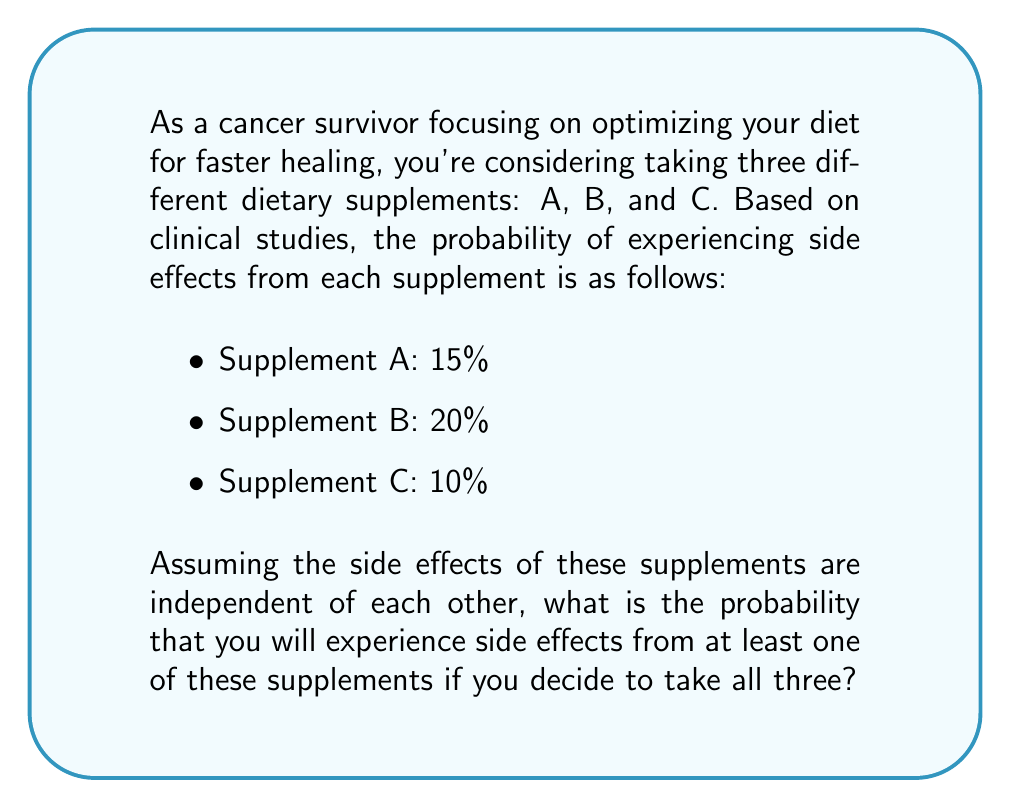Help me with this question. To solve this problem, we'll use the concept of probability of the complement event. Instead of calculating the probability of experiencing side effects from at least one supplement directly, we'll calculate the probability of not experiencing side effects from any of the supplements and then subtract that from 1.

Let's break it down step-by-step:

1) First, let's calculate the probability of not experiencing side effects for each supplement:
   - Supplement A: $1 - 0.15 = 0.85$ or $85\%$
   - Supplement B: $1 - 0.20 = 0.80$ or $80\%$
   - Supplement C: $1 - 0.10 = 0.90$ or $90\%$

2) Since the side effects are independent, the probability of not experiencing side effects from any of the supplements is the product of the individual probabilities:

   $$P(\text{no side effects}) = 0.85 \times 0.80 \times 0.90 = 0.612$$

3) Therefore, the probability of experiencing side effects from at least one supplement is the complement of this probability:

   $$P(\text{at least one side effect}) = 1 - P(\text{no side effects})$$
   $$P(\text{at least one side effect}) = 1 - 0.612 = 0.388$$

4) Converting to a percentage:

   $$0.388 \times 100\% = 38.8\%$$
Answer: The probability of experiencing side effects from at least one of the three supplements is 38.8%. 